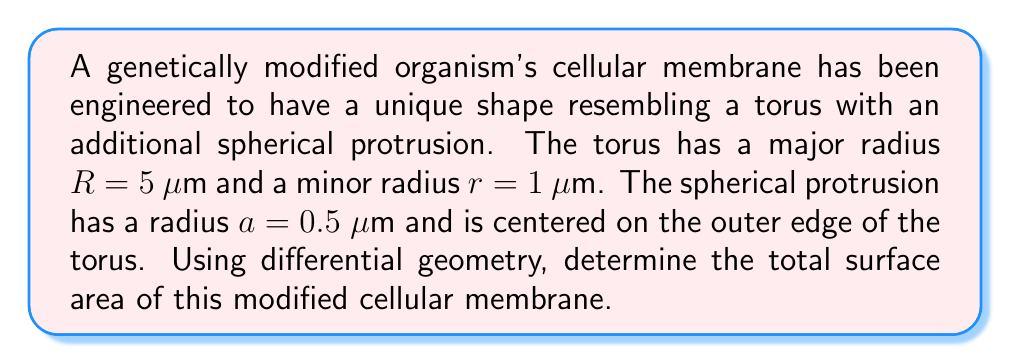What is the answer to this math problem? To solve this problem, we'll break it down into steps:

1. Calculate the surface area of the torus:
   The surface area of a torus is given by the formula:
   $$A_t = 4\pi^2Rr$$
   where $R$ is the major radius and $r$ is the minor radius.
   $$A_t = 4\pi^2 \cdot 5 \cdot 1 = 20\pi^2 \text{ μm}^2$$

2. Calculate the surface area of the spherical protrusion:
   The surface area of a sphere is given by:
   $$A_s = 4\pi a^2$$
   where $a$ is the radius of the sphere.
   $$A_s = 4\pi \cdot (0.5)^2 = \pi \text{ μm}^2$$

3. Calculate the area of the circular region where the sphere intersects the torus:
   The radius of this circular region is given by:
   $$r_{\text{intersection}} = a\sin\theta$$
   where $\theta$ is the angle between the normal of the torus surface and the line connecting the centers of the torus and sphere.
   $$\sin\theta = \frac{r}{R+r} = \frac{1}{6}$$
   $$r_{\text{intersection}} = 0.5 \cdot \frac{1}{6} = \frac{1}{12} \text{ μm}$$
   The area of this circular region is:
   $$A_i = \pi r_{\text{intersection}}^2 = \pi \cdot (\frac{1}{12})^2 = \frac{\pi}{144} \text{ μm}^2$$

4. Calculate the total surface area by adding the torus and sphere areas, then subtracting twice the intersection area (as it's counted twice):
   $$A_{\text{total}} = A_t + A_s - 2A_i$$
   $$A_{\text{total}} = 20\pi^2 + \pi - 2 \cdot \frac{\pi}{144}$$
   $$A_{\text{total}} = 20\pi^2 + \frac{71\pi}{72} \text{ μm}^2$$
Answer: $20\pi^2 + \frac{71\pi}{72} \text{ μm}^2$ 